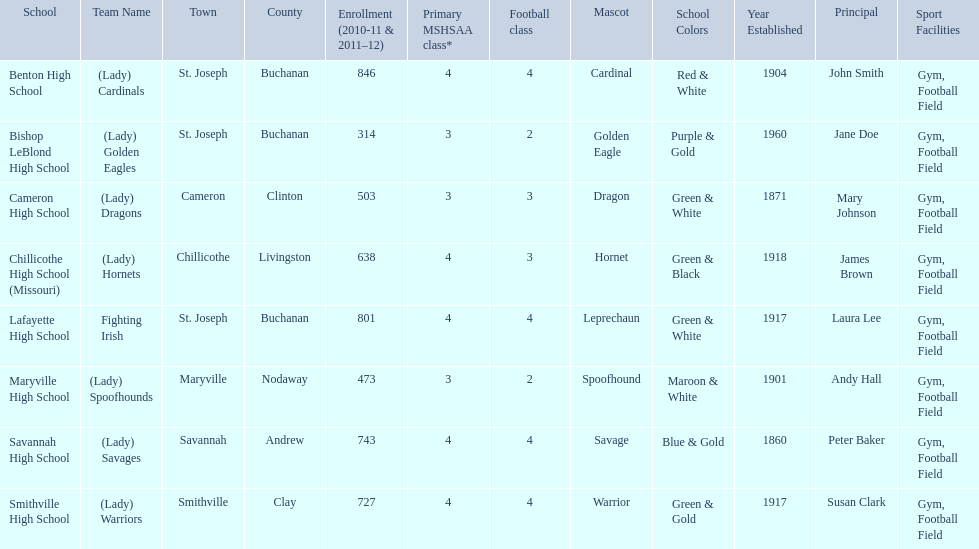What is the lowest number of students enrolled at a school as listed here? 314. What school has 314 students enrolled? Bishop LeBlond High School. 